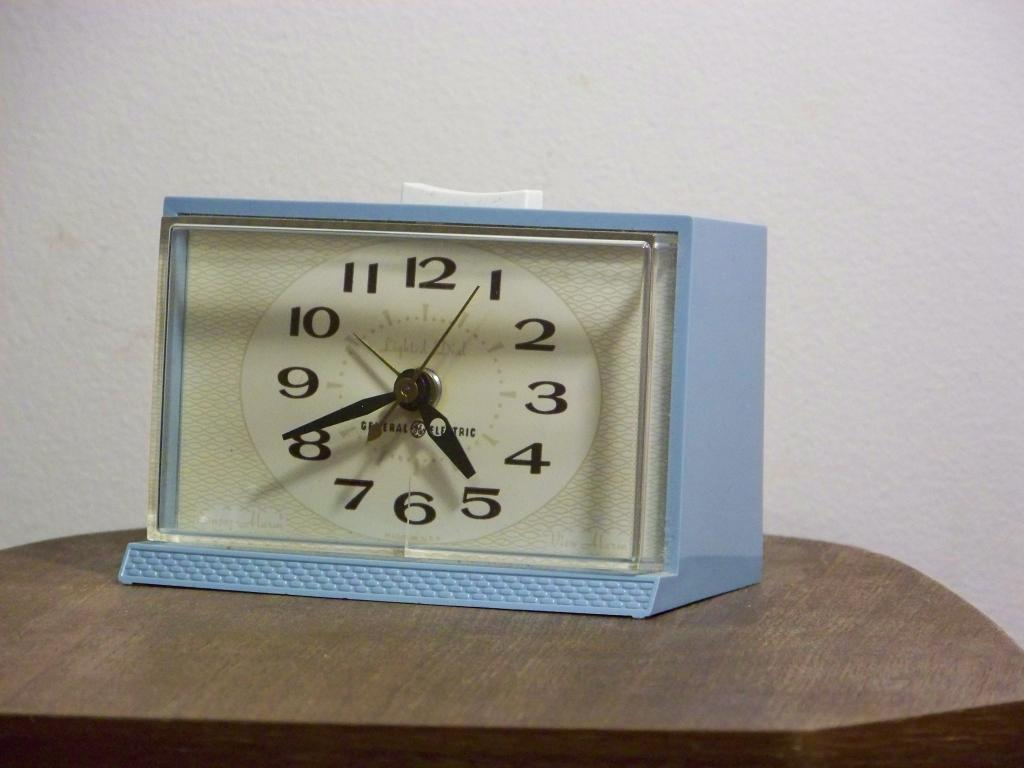<image>
Render a clear and concise summary of the photo. A vintage looking clock from General Electric shows that the time is a bit after 4:40. 